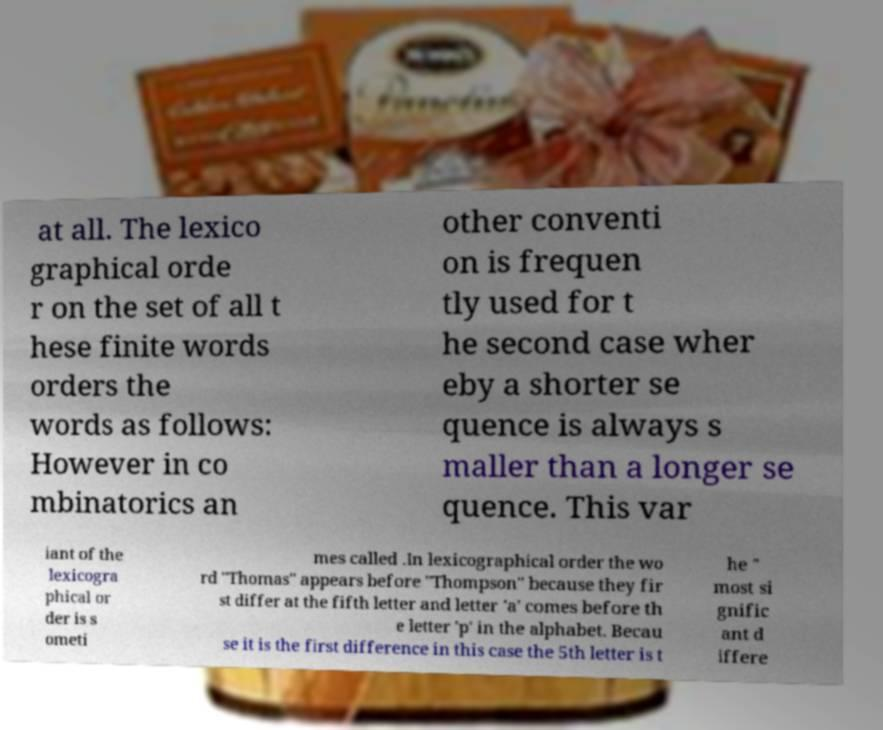Could you assist in decoding the text presented in this image and type it out clearly? at all. The lexico graphical orde r on the set of all t hese finite words orders the words as follows: However in co mbinatorics an other conventi on is frequen tly used for t he second case wher eby a shorter se quence is always s maller than a longer se quence. This var iant of the lexicogra phical or der is s ometi mes called .In lexicographical order the wo rd "Thomas" appears before "Thompson" because they fir st differ at the fifth letter and letter 'a' comes before th e letter 'p' in the alphabet. Becau se it is the first difference in this case the 5th letter is t he " most si gnific ant d iffere 